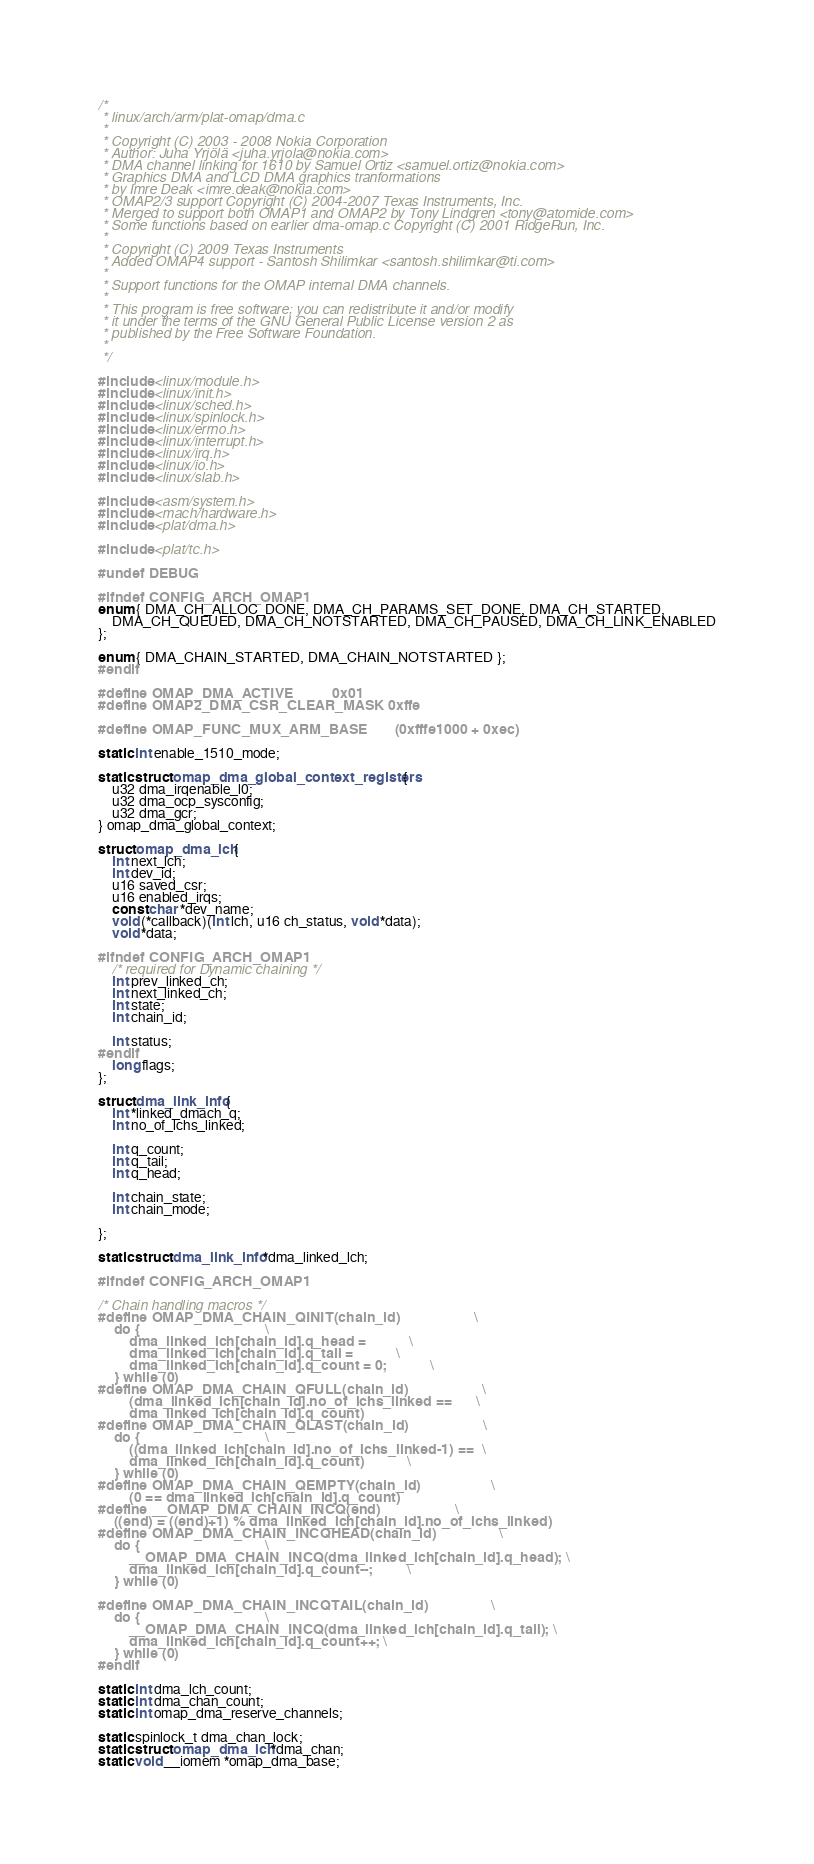<code> <loc_0><loc_0><loc_500><loc_500><_C_>/*
 * linux/arch/arm/plat-omap/dma.c
 *
 * Copyright (C) 2003 - 2008 Nokia Corporation
 * Author: Juha Yrjölä <juha.yrjola@nokia.com>
 * DMA channel linking for 1610 by Samuel Ortiz <samuel.ortiz@nokia.com>
 * Graphics DMA and LCD DMA graphics tranformations
 * by Imre Deak <imre.deak@nokia.com>
 * OMAP2/3 support Copyright (C) 2004-2007 Texas Instruments, Inc.
 * Merged to support both OMAP1 and OMAP2 by Tony Lindgren <tony@atomide.com>
 * Some functions based on earlier dma-omap.c Copyright (C) 2001 RidgeRun, Inc.
 *
 * Copyright (C) 2009 Texas Instruments
 * Added OMAP4 support - Santosh Shilimkar <santosh.shilimkar@ti.com>
 *
 * Support functions for the OMAP internal DMA channels.
 *
 * This program is free software; you can redistribute it and/or modify
 * it under the terms of the GNU General Public License version 2 as
 * published by the Free Software Foundation.
 *
 */

#include <linux/module.h>
#include <linux/init.h>
#include <linux/sched.h>
#include <linux/spinlock.h>
#include <linux/errno.h>
#include <linux/interrupt.h>
#include <linux/irq.h>
#include <linux/io.h>
#include <linux/slab.h>

#include <asm/system.h>
#include <mach/hardware.h>
#include <plat/dma.h>

#include <plat/tc.h>

#undef DEBUG

#ifndef CONFIG_ARCH_OMAP1
enum { DMA_CH_ALLOC_DONE, DMA_CH_PARAMS_SET_DONE, DMA_CH_STARTED,
	DMA_CH_QUEUED, DMA_CH_NOTSTARTED, DMA_CH_PAUSED, DMA_CH_LINK_ENABLED
};

enum { DMA_CHAIN_STARTED, DMA_CHAIN_NOTSTARTED };
#endif

#define OMAP_DMA_ACTIVE			0x01
#define OMAP2_DMA_CSR_CLEAR_MASK	0xffe

#define OMAP_FUNC_MUX_ARM_BASE		(0xfffe1000 + 0xec)

static int enable_1510_mode;

static struct omap_dma_global_context_registers {
	u32 dma_irqenable_l0;
	u32 dma_ocp_sysconfig;
	u32 dma_gcr;
} omap_dma_global_context;

struct omap_dma_lch {
	int next_lch;
	int dev_id;
	u16 saved_csr;
	u16 enabled_irqs;
	const char *dev_name;
	void (*callback)(int lch, u16 ch_status, void *data);
	void *data;

#ifndef CONFIG_ARCH_OMAP1
	/* required for Dynamic chaining */
	int prev_linked_ch;
	int next_linked_ch;
	int state;
	int chain_id;

	int status;
#endif
	long flags;
};

struct dma_link_info {
	int *linked_dmach_q;
	int no_of_lchs_linked;

	int q_count;
	int q_tail;
	int q_head;

	int chain_state;
	int chain_mode;

};

static struct dma_link_info *dma_linked_lch;

#ifndef CONFIG_ARCH_OMAP1

/* Chain handling macros */
#define OMAP_DMA_CHAIN_QINIT(chain_id)					\
	do {								\
		dma_linked_lch[chain_id].q_head =			\
		dma_linked_lch[chain_id].q_tail =			\
		dma_linked_lch[chain_id].q_count = 0;			\
	} while (0)
#define OMAP_DMA_CHAIN_QFULL(chain_id)					\
		(dma_linked_lch[chain_id].no_of_lchs_linked ==		\
		dma_linked_lch[chain_id].q_count)
#define OMAP_DMA_CHAIN_QLAST(chain_id)					\
	do {								\
		((dma_linked_lch[chain_id].no_of_lchs_linked-1) ==	\
		dma_linked_lch[chain_id].q_count)			\
	} while (0)
#define OMAP_DMA_CHAIN_QEMPTY(chain_id)					\
		(0 == dma_linked_lch[chain_id].q_count)
#define __OMAP_DMA_CHAIN_INCQ(end)					\
	((end) = ((end)+1) % dma_linked_lch[chain_id].no_of_lchs_linked)
#define OMAP_DMA_CHAIN_INCQHEAD(chain_id)				\
	do {								\
		__OMAP_DMA_CHAIN_INCQ(dma_linked_lch[chain_id].q_head);	\
		dma_linked_lch[chain_id].q_count--;			\
	} while (0)

#define OMAP_DMA_CHAIN_INCQTAIL(chain_id)				\
	do {								\
		__OMAP_DMA_CHAIN_INCQ(dma_linked_lch[chain_id].q_tail);	\
		dma_linked_lch[chain_id].q_count++; \
	} while (0)
#endif

static int dma_lch_count;
static int dma_chan_count;
static int omap_dma_reserve_channels;

static spinlock_t dma_chan_lock;
static struct omap_dma_lch *dma_chan;
static void __iomem *omap_dma_base;
</code> 